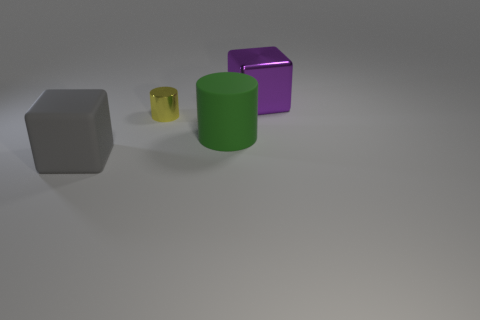Subtract all green cylinders. Subtract all red balls. How many cylinders are left? 1 Subtract all cyan blocks. How many brown cylinders are left? 0 Add 1 things. How many blues exist? 0 Subtract all big red rubber cylinders. Subtract all large shiny things. How many objects are left? 3 Add 1 rubber cubes. How many rubber cubes are left? 2 Add 1 matte things. How many matte things exist? 3 Add 1 brown blocks. How many objects exist? 5 Subtract all gray blocks. How many blocks are left? 1 Subtract 0 yellow blocks. How many objects are left? 4 Subtract 1 cylinders. How many cylinders are left? 1 